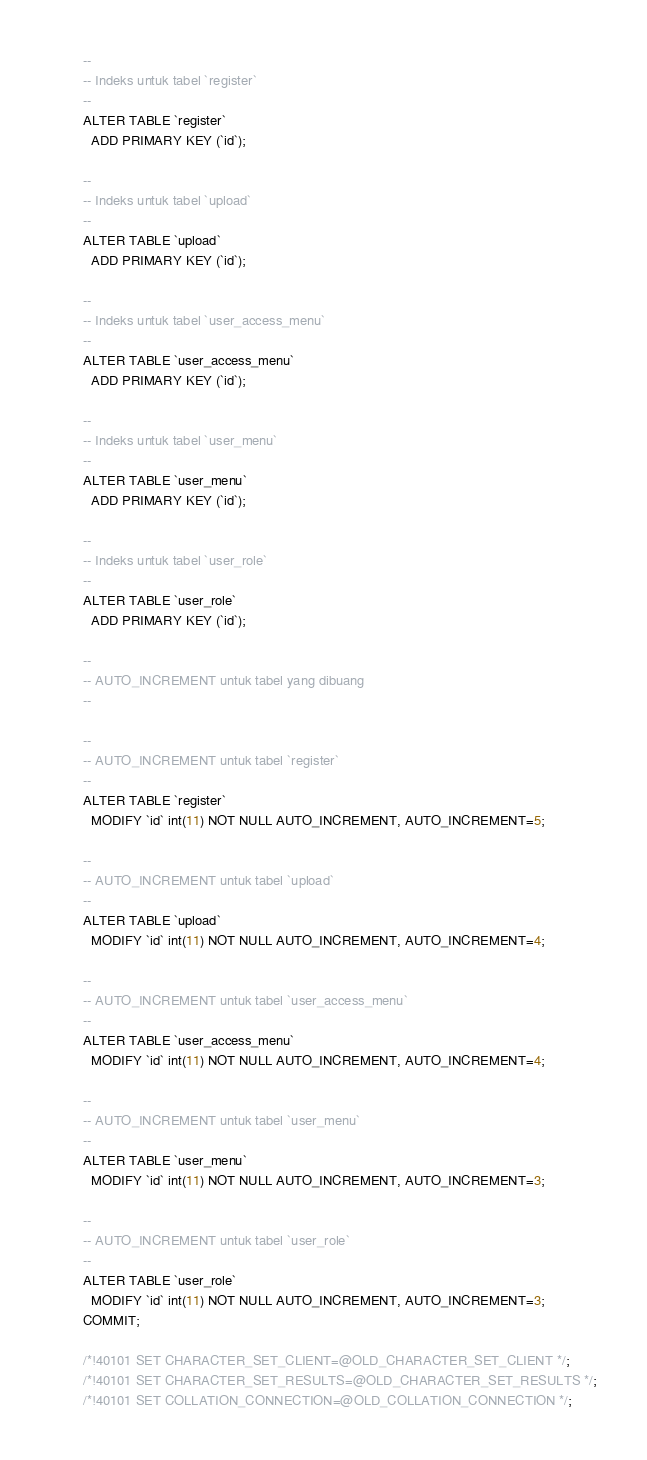<code> <loc_0><loc_0><loc_500><loc_500><_SQL_>--
-- Indeks untuk tabel `register`
--
ALTER TABLE `register`
  ADD PRIMARY KEY (`id`);

--
-- Indeks untuk tabel `upload`
--
ALTER TABLE `upload`
  ADD PRIMARY KEY (`id`);

--
-- Indeks untuk tabel `user_access_menu`
--
ALTER TABLE `user_access_menu`
  ADD PRIMARY KEY (`id`);

--
-- Indeks untuk tabel `user_menu`
--
ALTER TABLE `user_menu`
  ADD PRIMARY KEY (`id`);

--
-- Indeks untuk tabel `user_role`
--
ALTER TABLE `user_role`
  ADD PRIMARY KEY (`id`);

--
-- AUTO_INCREMENT untuk tabel yang dibuang
--

--
-- AUTO_INCREMENT untuk tabel `register`
--
ALTER TABLE `register`
  MODIFY `id` int(11) NOT NULL AUTO_INCREMENT, AUTO_INCREMENT=5;

--
-- AUTO_INCREMENT untuk tabel `upload`
--
ALTER TABLE `upload`
  MODIFY `id` int(11) NOT NULL AUTO_INCREMENT, AUTO_INCREMENT=4;

--
-- AUTO_INCREMENT untuk tabel `user_access_menu`
--
ALTER TABLE `user_access_menu`
  MODIFY `id` int(11) NOT NULL AUTO_INCREMENT, AUTO_INCREMENT=4;

--
-- AUTO_INCREMENT untuk tabel `user_menu`
--
ALTER TABLE `user_menu`
  MODIFY `id` int(11) NOT NULL AUTO_INCREMENT, AUTO_INCREMENT=3;

--
-- AUTO_INCREMENT untuk tabel `user_role`
--
ALTER TABLE `user_role`
  MODIFY `id` int(11) NOT NULL AUTO_INCREMENT, AUTO_INCREMENT=3;
COMMIT;

/*!40101 SET CHARACTER_SET_CLIENT=@OLD_CHARACTER_SET_CLIENT */;
/*!40101 SET CHARACTER_SET_RESULTS=@OLD_CHARACTER_SET_RESULTS */;
/*!40101 SET COLLATION_CONNECTION=@OLD_COLLATION_CONNECTION */;
</code> 